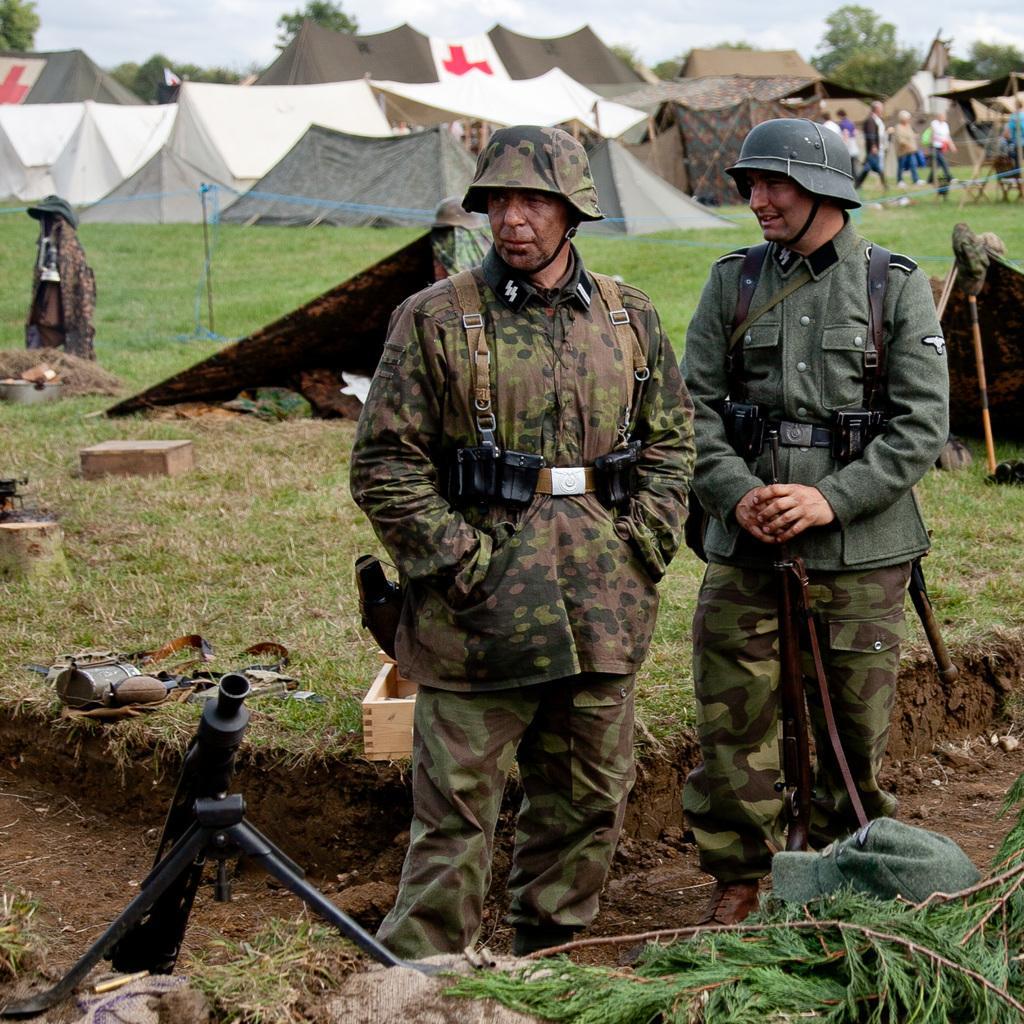Describe this image in one or two sentences. In this picture we can see there are two people standing and a man is holding a gun. In front of the two men there is a cap and a stand. Behind the two men there is a net, tents and some objects. On the right side of the tents, there are some people walking. Behind the tents, there are trees and the sky. 